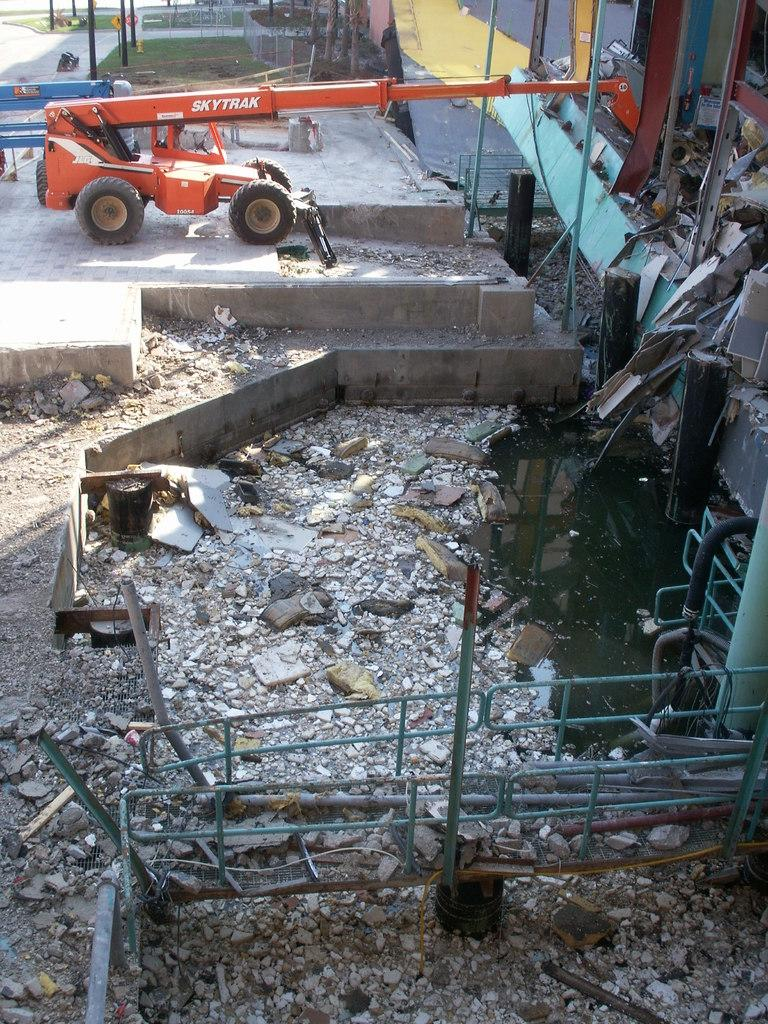What is the main object on the ground in the image? There is a vehicle on the ground in the image. What type of natural elements can be seen in the image? There are stones and grass visible in the image. What are the long, thin objects in the image? There are rods in the image. What can be seen in the background of the image? There are poles visible in the background of the image. What type of suit is the man wearing in the image? There is no man present in the image, so it is not possible to determine what type of suit he might be wearing. 